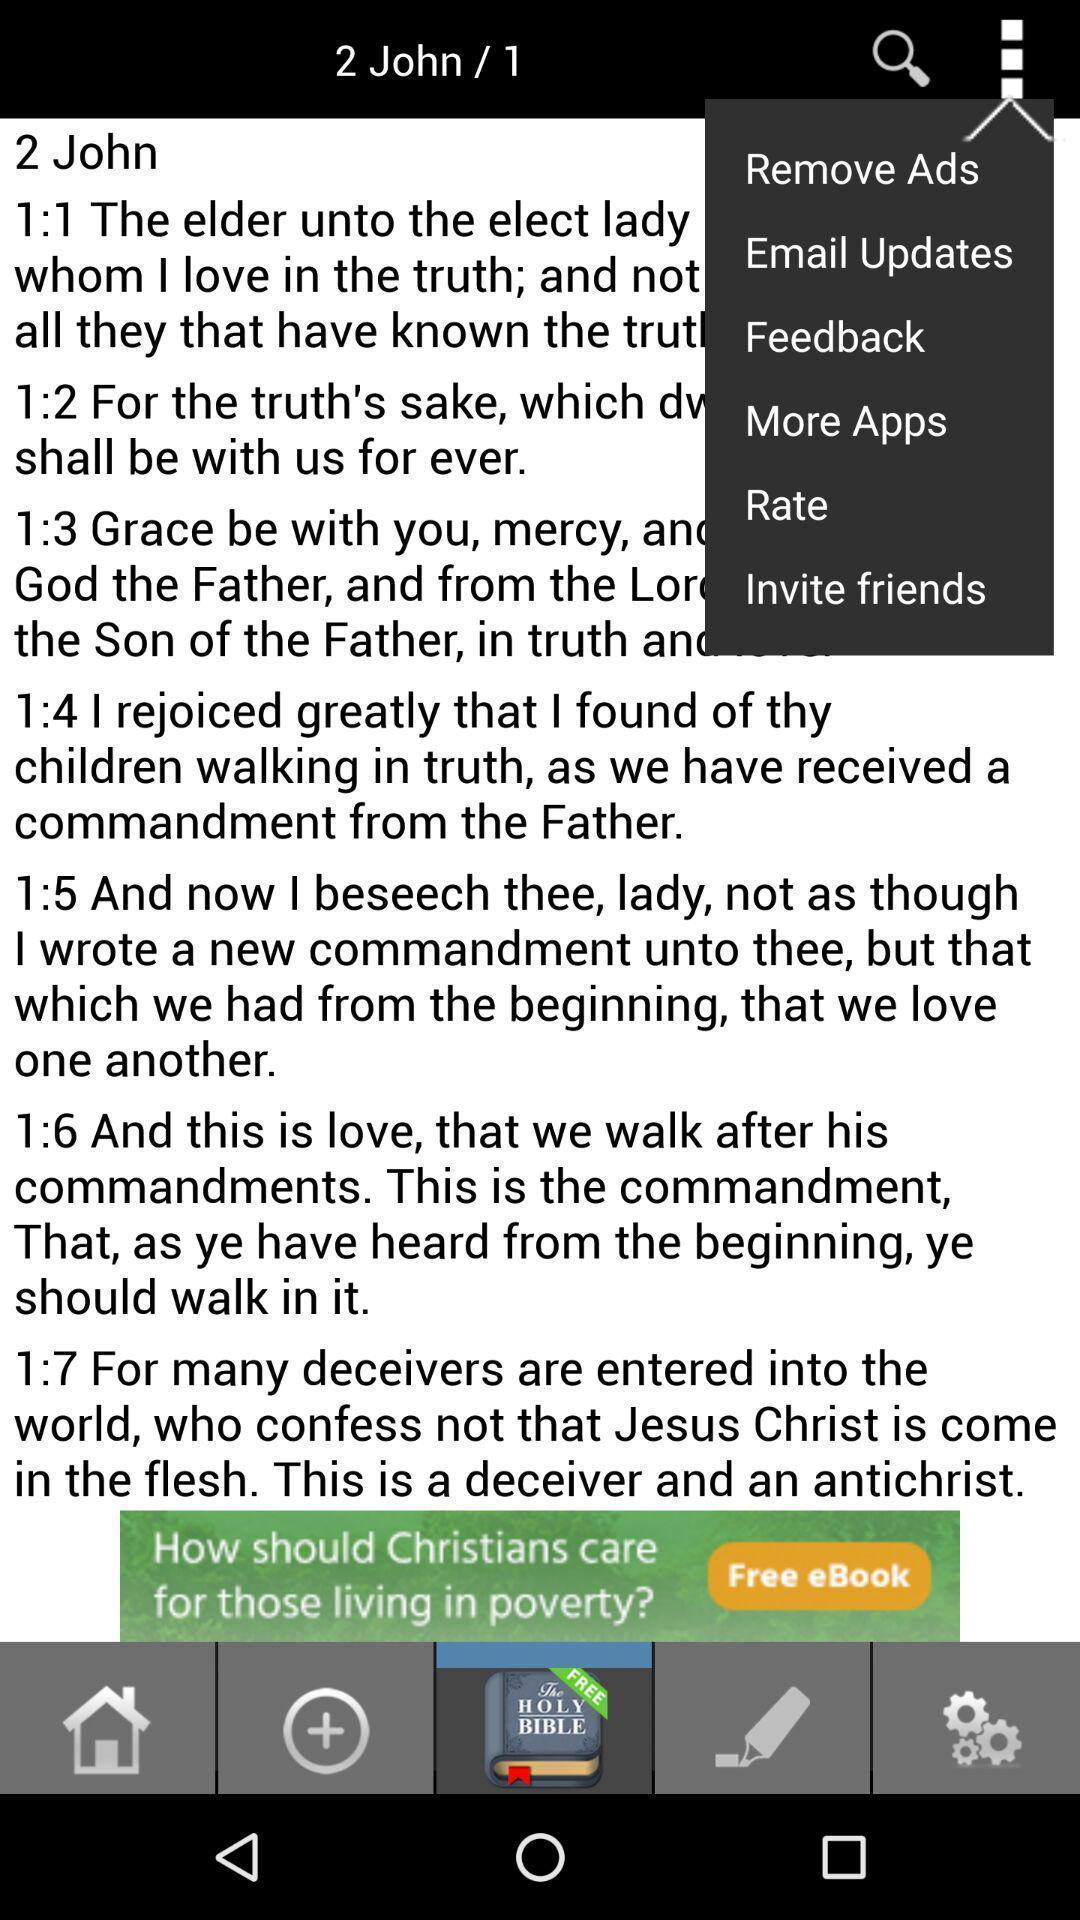What can you discern from this picture? Screen displaying multiple control options of an article. 